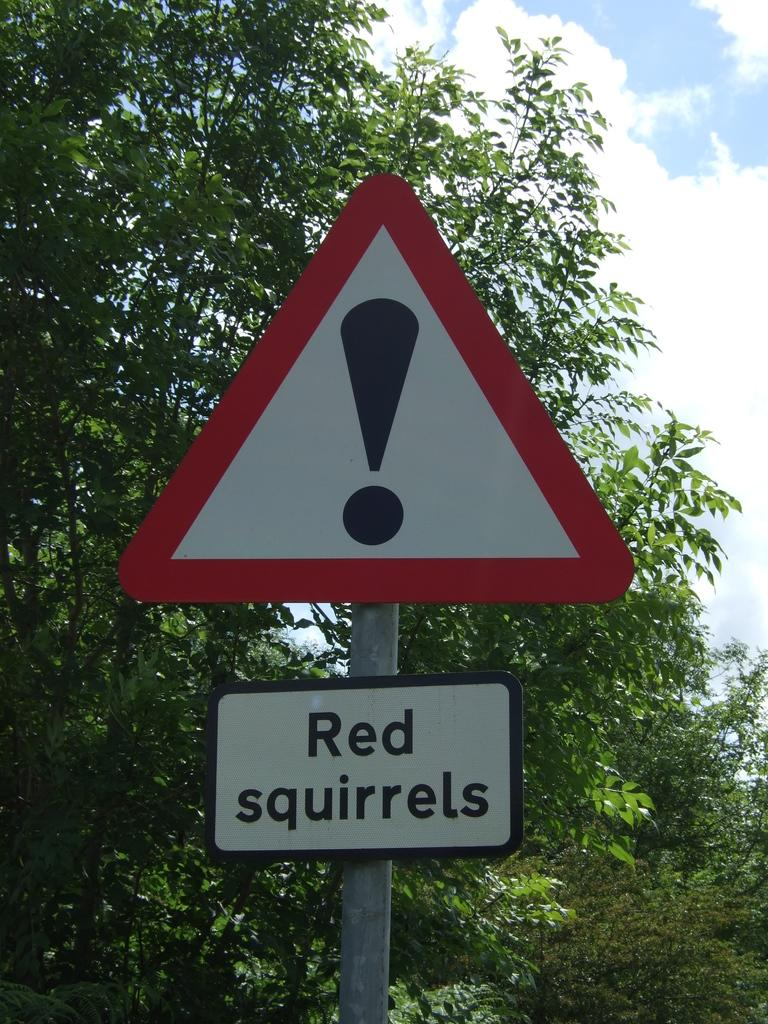What is the main object in the image? There is a sign board pole in the image. What is attached to the pole? There is a name board on the pole. What can be seen in the background of the image? There are trees and clouds in the sky in the background of the image. What type of wool is being used to make the name board in the image? There is no wool present in the image, as the name board is not made of wool. 